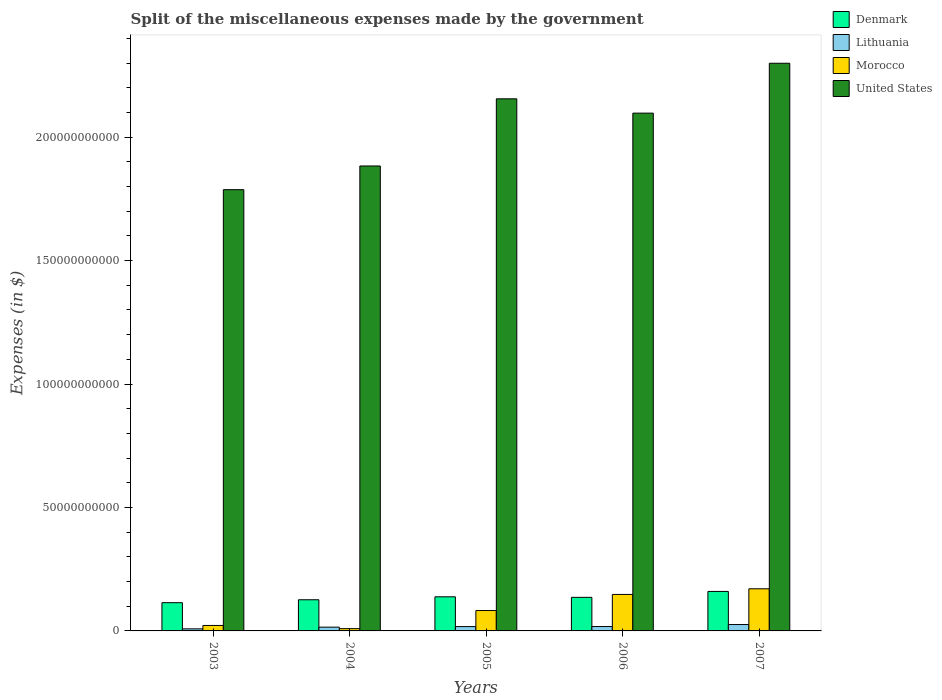How many groups of bars are there?
Your response must be concise. 5. How many bars are there on the 3rd tick from the right?
Offer a very short reply. 4. What is the label of the 3rd group of bars from the left?
Ensure brevity in your answer.  2005. In how many cases, is the number of bars for a given year not equal to the number of legend labels?
Your answer should be very brief. 0. What is the miscellaneous expenses made by the government in Lithuania in 2003?
Your answer should be very brief. 8.38e+08. Across all years, what is the maximum miscellaneous expenses made by the government in Denmark?
Offer a very short reply. 1.60e+1. Across all years, what is the minimum miscellaneous expenses made by the government in Morocco?
Provide a succinct answer. 9.22e+08. What is the total miscellaneous expenses made by the government in Lithuania in the graph?
Your response must be concise. 8.48e+09. What is the difference between the miscellaneous expenses made by the government in Denmark in 2004 and that in 2007?
Give a very brief answer. -3.37e+09. What is the difference between the miscellaneous expenses made by the government in Morocco in 2003 and the miscellaneous expenses made by the government in Lithuania in 2006?
Ensure brevity in your answer.  4.33e+08. What is the average miscellaneous expenses made by the government in United States per year?
Provide a succinct answer. 2.04e+11. In the year 2006, what is the difference between the miscellaneous expenses made by the government in Morocco and miscellaneous expenses made by the government in Denmark?
Provide a short and direct response. 1.18e+09. What is the ratio of the miscellaneous expenses made by the government in Morocco in 2004 to that in 2007?
Keep it short and to the point. 0.05. Is the miscellaneous expenses made by the government in Lithuania in 2003 less than that in 2007?
Keep it short and to the point. Yes. Is the difference between the miscellaneous expenses made by the government in Morocco in 2003 and 2005 greater than the difference between the miscellaneous expenses made by the government in Denmark in 2003 and 2005?
Keep it short and to the point. No. What is the difference between the highest and the second highest miscellaneous expenses made by the government in Denmark?
Provide a succinct answer. 2.17e+09. What is the difference between the highest and the lowest miscellaneous expenses made by the government in Denmark?
Offer a terse response. 4.55e+09. In how many years, is the miscellaneous expenses made by the government in Lithuania greater than the average miscellaneous expenses made by the government in Lithuania taken over all years?
Make the answer very short. 3. Is it the case that in every year, the sum of the miscellaneous expenses made by the government in United States and miscellaneous expenses made by the government in Denmark is greater than the sum of miscellaneous expenses made by the government in Morocco and miscellaneous expenses made by the government in Lithuania?
Your response must be concise. Yes. What does the 4th bar from the right in 2007 represents?
Provide a short and direct response. Denmark. How many bars are there?
Provide a succinct answer. 20. Are all the bars in the graph horizontal?
Your answer should be compact. No. How many years are there in the graph?
Keep it short and to the point. 5. What is the difference between two consecutive major ticks on the Y-axis?
Make the answer very short. 5.00e+1. Are the values on the major ticks of Y-axis written in scientific E-notation?
Keep it short and to the point. No. Does the graph contain any zero values?
Your answer should be compact. No. Where does the legend appear in the graph?
Keep it short and to the point. Top right. How many legend labels are there?
Your answer should be very brief. 4. What is the title of the graph?
Give a very brief answer. Split of the miscellaneous expenses made by the government. What is the label or title of the X-axis?
Offer a very short reply. Years. What is the label or title of the Y-axis?
Make the answer very short. Expenses (in $). What is the Expenses (in $) in Denmark in 2003?
Provide a short and direct response. 1.14e+1. What is the Expenses (in $) of Lithuania in 2003?
Provide a short and direct response. 8.38e+08. What is the Expenses (in $) of Morocco in 2003?
Keep it short and to the point. 2.21e+09. What is the Expenses (in $) in United States in 2003?
Ensure brevity in your answer.  1.79e+11. What is the Expenses (in $) in Denmark in 2004?
Make the answer very short. 1.26e+1. What is the Expenses (in $) of Lithuania in 2004?
Offer a very short reply. 1.53e+09. What is the Expenses (in $) of Morocco in 2004?
Your response must be concise. 9.22e+08. What is the Expenses (in $) of United States in 2004?
Keep it short and to the point. 1.88e+11. What is the Expenses (in $) in Denmark in 2005?
Make the answer very short. 1.38e+1. What is the Expenses (in $) in Lithuania in 2005?
Provide a short and direct response. 1.75e+09. What is the Expenses (in $) of Morocco in 2005?
Provide a succinct answer. 8.26e+09. What is the Expenses (in $) in United States in 2005?
Offer a very short reply. 2.16e+11. What is the Expenses (in $) in Denmark in 2006?
Offer a terse response. 1.36e+1. What is the Expenses (in $) of Lithuania in 2006?
Offer a very short reply. 1.78e+09. What is the Expenses (in $) of Morocco in 2006?
Your answer should be very brief. 1.48e+1. What is the Expenses (in $) of United States in 2006?
Your response must be concise. 2.10e+11. What is the Expenses (in $) in Denmark in 2007?
Your response must be concise. 1.60e+1. What is the Expenses (in $) of Lithuania in 2007?
Provide a short and direct response. 2.58e+09. What is the Expenses (in $) in Morocco in 2007?
Provide a short and direct response. 1.71e+1. What is the Expenses (in $) in United States in 2007?
Offer a very short reply. 2.30e+11. Across all years, what is the maximum Expenses (in $) of Denmark?
Provide a succinct answer. 1.60e+1. Across all years, what is the maximum Expenses (in $) of Lithuania?
Keep it short and to the point. 2.58e+09. Across all years, what is the maximum Expenses (in $) in Morocco?
Your response must be concise. 1.71e+1. Across all years, what is the maximum Expenses (in $) in United States?
Provide a succinct answer. 2.30e+11. Across all years, what is the minimum Expenses (in $) of Denmark?
Provide a succinct answer. 1.14e+1. Across all years, what is the minimum Expenses (in $) of Lithuania?
Ensure brevity in your answer.  8.38e+08. Across all years, what is the minimum Expenses (in $) in Morocco?
Keep it short and to the point. 9.22e+08. Across all years, what is the minimum Expenses (in $) in United States?
Your response must be concise. 1.79e+11. What is the total Expenses (in $) of Denmark in the graph?
Your response must be concise. 6.75e+1. What is the total Expenses (in $) of Lithuania in the graph?
Your answer should be very brief. 8.48e+09. What is the total Expenses (in $) in Morocco in the graph?
Give a very brief answer. 4.32e+1. What is the total Expenses (in $) in United States in the graph?
Your answer should be compact. 1.02e+12. What is the difference between the Expenses (in $) of Denmark in 2003 and that in 2004?
Give a very brief answer. -1.18e+09. What is the difference between the Expenses (in $) in Lithuania in 2003 and that in 2004?
Offer a very short reply. -6.93e+08. What is the difference between the Expenses (in $) in Morocco in 2003 and that in 2004?
Provide a short and direct response. 1.29e+09. What is the difference between the Expenses (in $) of United States in 2003 and that in 2004?
Provide a short and direct response. -9.60e+09. What is the difference between the Expenses (in $) of Denmark in 2003 and that in 2005?
Ensure brevity in your answer.  -2.38e+09. What is the difference between the Expenses (in $) in Lithuania in 2003 and that in 2005?
Your answer should be compact. -9.16e+08. What is the difference between the Expenses (in $) in Morocco in 2003 and that in 2005?
Offer a very short reply. -6.05e+09. What is the difference between the Expenses (in $) in United States in 2003 and that in 2005?
Make the answer very short. -3.68e+1. What is the difference between the Expenses (in $) of Denmark in 2003 and that in 2006?
Offer a very short reply. -2.16e+09. What is the difference between the Expenses (in $) in Lithuania in 2003 and that in 2006?
Provide a succinct answer. -9.38e+08. What is the difference between the Expenses (in $) of Morocco in 2003 and that in 2006?
Your response must be concise. -1.26e+1. What is the difference between the Expenses (in $) in United States in 2003 and that in 2006?
Keep it short and to the point. -3.10e+1. What is the difference between the Expenses (in $) in Denmark in 2003 and that in 2007?
Your response must be concise. -4.55e+09. What is the difference between the Expenses (in $) in Lithuania in 2003 and that in 2007?
Keep it short and to the point. -1.74e+09. What is the difference between the Expenses (in $) of Morocco in 2003 and that in 2007?
Offer a very short reply. -1.49e+1. What is the difference between the Expenses (in $) of United States in 2003 and that in 2007?
Provide a short and direct response. -5.12e+1. What is the difference between the Expenses (in $) in Denmark in 2004 and that in 2005?
Keep it short and to the point. -1.20e+09. What is the difference between the Expenses (in $) in Lithuania in 2004 and that in 2005?
Your response must be concise. -2.23e+08. What is the difference between the Expenses (in $) in Morocco in 2004 and that in 2005?
Your response must be concise. -7.33e+09. What is the difference between the Expenses (in $) of United States in 2004 and that in 2005?
Give a very brief answer. -2.72e+1. What is the difference between the Expenses (in $) in Denmark in 2004 and that in 2006?
Ensure brevity in your answer.  -9.76e+08. What is the difference between the Expenses (in $) in Lithuania in 2004 and that in 2006?
Provide a short and direct response. -2.45e+08. What is the difference between the Expenses (in $) of Morocco in 2004 and that in 2006?
Give a very brief answer. -1.38e+1. What is the difference between the Expenses (in $) in United States in 2004 and that in 2006?
Offer a very short reply. -2.14e+1. What is the difference between the Expenses (in $) in Denmark in 2004 and that in 2007?
Your answer should be compact. -3.37e+09. What is the difference between the Expenses (in $) in Lithuania in 2004 and that in 2007?
Ensure brevity in your answer.  -1.05e+09. What is the difference between the Expenses (in $) of Morocco in 2004 and that in 2007?
Ensure brevity in your answer.  -1.61e+1. What is the difference between the Expenses (in $) of United States in 2004 and that in 2007?
Your response must be concise. -4.16e+1. What is the difference between the Expenses (in $) of Denmark in 2005 and that in 2006?
Ensure brevity in your answer.  2.23e+08. What is the difference between the Expenses (in $) of Lithuania in 2005 and that in 2006?
Keep it short and to the point. -2.16e+07. What is the difference between the Expenses (in $) of Morocco in 2005 and that in 2006?
Your response must be concise. -6.52e+09. What is the difference between the Expenses (in $) of United States in 2005 and that in 2006?
Ensure brevity in your answer.  5.80e+09. What is the difference between the Expenses (in $) of Denmark in 2005 and that in 2007?
Offer a terse response. -2.17e+09. What is the difference between the Expenses (in $) in Lithuania in 2005 and that in 2007?
Provide a short and direct response. -8.28e+08. What is the difference between the Expenses (in $) in Morocco in 2005 and that in 2007?
Provide a short and direct response. -8.81e+09. What is the difference between the Expenses (in $) in United States in 2005 and that in 2007?
Your response must be concise. -1.44e+1. What is the difference between the Expenses (in $) of Denmark in 2006 and that in 2007?
Your answer should be very brief. -2.40e+09. What is the difference between the Expenses (in $) in Lithuania in 2006 and that in 2007?
Keep it short and to the point. -8.07e+08. What is the difference between the Expenses (in $) of Morocco in 2006 and that in 2007?
Make the answer very short. -2.29e+09. What is the difference between the Expenses (in $) in United States in 2006 and that in 2007?
Provide a succinct answer. -2.02e+1. What is the difference between the Expenses (in $) in Denmark in 2003 and the Expenses (in $) in Lithuania in 2004?
Offer a terse response. 9.91e+09. What is the difference between the Expenses (in $) in Denmark in 2003 and the Expenses (in $) in Morocco in 2004?
Give a very brief answer. 1.05e+1. What is the difference between the Expenses (in $) of Denmark in 2003 and the Expenses (in $) of United States in 2004?
Provide a short and direct response. -1.77e+11. What is the difference between the Expenses (in $) in Lithuania in 2003 and the Expenses (in $) in Morocco in 2004?
Provide a succinct answer. -8.35e+07. What is the difference between the Expenses (in $) in Lithuania in 2003 and the Expenses (in $) in United States in 2004?
Provide a short and direct response. -1.87e+11. What is the difference between the Expenses (in $) in Morocco in 2003 and the Expenses (in $) in United States in 2004?
Your answer should be very brief. -1.86e+11. What is the difference between the Expenses (in $) in Denmark in 2003 and the Expenses (in $) in Lithuania in 2005?
Offer a terse response. 9.68e+09. What is the difference between the Expenses (in $) of Denmark in 2003 and the Expenses (in $) of Morocco in 2005?
Your answer should be very brief. 3.18e+09. What is the difference between the Expenses (in $) of Denmark in 2003 and the Expenses (in $) of United States in 2005?
Your response must be concise. -2.04e+11. What is the difference between the Expenses (in $) in Lithuania in 2003 and the Expenses (in $) in Morocco in 2005?
Keep it short and to the point. -7.42e+09. What is the difference between the Expenses (in $) in Lithuania in 2003 and the Expenses (in $) in United States in 2005?
Ensure brevity in your answer.  -2.15e+11. What is the difference between the Expenses (in $) of Morocco in 2003 and the Expenses (in $) of United States in 2005?
Ensure brevity in your answer.  -2.13e+11. What is the difference between the Expenses (in $) of Denmark in 2003 and the Expenses (in $) of Lithuania in 2006?
Give a very brief answer. 9.66e+09. What is the difference between the Expenses (in $) of Denmark in 2003 and the Expenses (in $) of Morocco in 2006?
Keep it short and to the point. -3.33e+09. What is the difference between the Expenses (in $) in Denmark in 2003 and the Expenses (in $) in United States in 2006?
Provide a succinct answer. -1.98e+11. What is the difference between the Expenses (in $) in Lithuania in 2003 and the Expenses (in $) in Morocco in 2006?
Make the answer very short. -1.39e+1. What is the difference between the Expenses (in $) in Lithuania in 2003 and the Expenses (in $) in United States in 2006?
Your answer should be compact. -2.09e+11. What is the difference between the Expenses (in $) in Morocco in 2003 and the Expenses (in $) in United States in 2006?
Offer a very short reply. -2.07e+11. What is the difference between the Expenses (in $) in Denmark in 2003 and the Expenses (in $) in Lithuania in 2007?
Your answer should be very brief. 8.86e+09. What is the difference between the Expenses (in $) of Denmark in 2003 and the Expenses (in $) of Morocco in 2007?
Offer a very short reply. -5.63e+09. What is the difference between the Expenses (in $) in Denmark in 2003 and the Expenses (in $) in United States in 2007?
Your answer should be compact. -2.18e+11. What is the difference between the Expenses (in $) of Lithuania in 2003 and the Expenses (in $) of Morocco in 2007?
Your response must be concise. -1.62e+1. What is the difference between the Expenses (in $) in Lithuania in 2003 and the Expenses (in $) in United States in 2007?
Your response must be concise. -2.29e+11. What is the difference between the Expenses (in $) in Morocco in 2003 and the Expenses (in $) in United States in 2007?
Give a very brief answer. -2.28e+11. What is the difference between the Expenses (in $) in Denmark in 2004 and the Expenses (in $) in Lithuania in 2005?
Offer a terse response. 1.09e+1. What is the difference between the Expenses (in $) of Denmark in 2004 and the Expenses (in $) of Morocco in 2005?
Give a very brief answer. 4.36e+09. What is the difference between the Expenses (in $) of Denmark in 2004 and the Expenses (in $) of United States in 2005?
Your response must be concise. -2.03e+11. What is the difference between the Expenses (in $) of Lithuania in 2004 and the Expenses (in $) of Morocco in 2005?
Provide a short and direct response. -6.72e+09. What is the difference between the Expenses (in $) in Lithuania in 2004 and the Expenses (in $) in United States in 2005?
Provide a succinct answer. -2.14e+11. What is the difference between the Expenses (in $) in Morocco in 2004 and the Expenses (in $) in United States in 2005?
Provide a succinct answer. -2.15e+11. What is the difference between the Expenses (in $) in Denmark in 2004 and the Expenses (in $) in Lithuania in 2006?
Provide a short and direct response. 1.08e+1. What is the difference between the Expenses (in $) in Denmark in 2004 and the Expenses (in $) in Morocco in 2006?
Make the answer very short. -2.15e+09. What is the difference between the Expenses (in $) of Denmark in 2004 and the Expenses (in $) of United States in 2006?
Your response must be concise. -1.97e+11. What is the difference between the Expenses (in $) of Lithuania in 2004 and the Expenses (in $) of Morocco in 2006?
Your answer should be compact. -1.32e+1. What is the difference between the Expenses (in $) of Lithuania in 2004 and the Expenses (in $) of United States in 2006?
Your answer should be compact. -2.08e+11. What is the difference between the Expenses (in $) of Morocco in 2004 and the Expenses (in $) of United States in 2006?
Provide a succinct answer. -2.09e+11. What is the difference between the Expenses (in $) in Denmark in 2004 and the Expenses (in $) in Lithuania in 2007?
Your answer should be compact. 1.00e+1. What is the difference between the Expenses (in $) in Denmark in 2004 and the Expenses (in $) in Morocco in 2007?
Your answer should be compact. -4.44e+09. What is the difference between the Expenses (in $) in Denmark in 2004 and the Expenses (in $) in United States in 2007?
Your answer should be compact. -2.17e+11. What is the difference between the Expenses (in $) in Lithuania in 2004 and the Expenses (in $) in Morocco in 2007?
Your answer should be very brief. -1.55e+1. What is the difference between the Expenses (in $) in Lithuania in 2004 and the Expenses (in $) in United States in 2007?
Provide a succinct answer. -2.28e+11. What is the difference between the Expenses (in $) of Morocco in 2004 and the Expenses (in $) of United States in 2007?
Your answer should be very brief. -2.29e+11. What is the difference between the Expenses (in $) of Denmark in 2005 and the Expenses (in $) of Lithuania in 2006?
Ensure brevity in your answer.  1.20e+1. What is the difference between the Expenses (in $) in Denmark in 2005 and the Expenses (in $) in Morocco in 2006?
Provide a short and direct response. -9.52e+08. What is the difference between the Expenses (in $) in Denmark in 2005 and the Expenses (in $) in United States in 2006?
Ensure brevity in your answer.  -1.96e+11. What is the difference between the Expenses (in $) in Lithuania in 2005 and the Expenses (in $) in Morocco in 2006?
Provide a short and direct response. -1.30e+1. What is the difference between the Expenses (in $) in Lithuania in 2005 and the Expenses (in $) in United States in 2006?
Your answer should be very brief. -2.08e+11. What is the difference between the Expenses (in $) of Morocco in 2005 and the Expenses (in $) of United States in 2006?
Your answer should be very brief. -2.01e+11. What is the difference between the Expenses (in $) in Denmark in 2005 and the Expenses (in $) in Lithuania in 2007?
Provide a succinct answer. 1.12e+1. What is the difference between the Expenses (in $) in Denmark in 2005 and the Expenses (in $) in Morocco in 2007?
Your response must be concise. -3.25e+09. What is the difference between the Expenses (in $) in Denmark in 2005 and the Expenses (in $) in United States in 2007?
Your answer should be compact. -2.16e+11. What is the difference between the Expenses (in $) of Lithuania in 2005 and the Expenses (in $) of Morocco in 2007?
Give a very brief answer. -1.53e+1. What is the difference between the Expenses (in $) in Lithuania in 2005 and the Expenses (in $) in United States in 2007?
Provide a short and direct response. -2.28e+11. What is the difference between the Expenses (in $) of Morocco in 2005 and the Expenses (in $) of United States in 2007?
Keep it short and to the point. -2.22e+11. What is the difference between the Expenses (in $) of Denmark in 2006 and the Expenses (in $) of Lithuania in 2007?
Give a very brief answer. 1.10e+1. What is the difference between the Expenses (in $) in Denmark in 2006 and the Expenses (in $) in Morocco in 2007?
Make the answer very short. -3.47e+09. What is the difference between the Expenses (in $) of Denmark in 2006 and the Expenses (in $) of United States in 2007?
Offer a terse response. -2.16e+11. What is the difference between the Expenses (in $) of Lithuania in 2006 and the Expenses (in $) of Morocco in 2007?
Offer a terse response. -1.53e+1. What is the difference between the Expenses (in $) in Lithuania in 2006 and the Expenses (in $) in United States in 2007?
Your answer should be compact. -2.28e+11. What is the difference between the Expenses (in $) of Morocco in 2006 and the Expenses (in $) of United States in 2007?
Offer a very short reply. -2.15e+11. What is the average Expenses (in $) of Denmark per year?
Your response must be concise. 1.35e+1. What is the average Expenses (in $) of Lithuania per year?
Offer a terse response. 1.70e+09. What is the average Expenses (in $) in Morocco per year?
Your answer should be very brief. 8.64e+09. What is the average Expenses (in $) in United States per year?
Provide a succinct answer. 2.04e+11. In the year 2003, what is the difference between the Expenses (in $) in Denmark and Expenses (in $) in Lithuania?
Provide a short and direct response. 1.06e+1. In the year 2003, what is the difference between the Expenses (in $) of Denmark and Expenses (in $) of Morocco?
Your answer should be very brief. 9.23e+09. In the year 2003, what is the difference between the Expenses (in $) in Denmark and Expenses (in $) in United States?
Keep it short and to the point. -1.67e+11. In the year 2003, what is the difference between the Expenses (in $) of Lithuania and Expenses (in $) of Morocco?
Your answer should be very brief. -1.37e+09. In the year 2003, what is the difference between the Expenses (in $) in Lithuania and Expenses (in $) in United States?
Give a very brief answer. -1.78e+11. In the year 2003, what is the difference between the Expenses (in $) in Morocco and Expenses (in $) in United States?
Your answer should be very brief. -1.76e+11. In the year 2004, what is the difference between the Expenses (in $) of Denmark and Expenses (in $) of Lithuania?
Make the answer very short. 1.11e+1. In the year 2004, what is the difference between the Expenses (in $) in Denmark and Expenses (in $) in Morocco?
Ensure brevity in your answer.  1.17e+1. In the year 2004, what is the difference between the Expenses (in $) of Denmark and Expenses (in $) of United States?
Offer a terse response. -1.76e+11. In the year 2004, what is the difference between the Expenses (in $) of Lithuania and Expenses (in $) of Morocco?
Make the answer very short. 6.09e+08. In the year 2004, what is the difference between the Expenses (in $) of Lithuania and Expenses (in $) of United States?
Your answer should be compact. -1.87e+11. In the year 2004, what is the difference between the Expenses (in $) in Morocco and Expenses (in $) in United States?
Provide a short and direct response. -1.87e+11. In the year 2005, what is the difference between the Expenses (in $) in Denmark and Expenses (in $) in Lithuania?
Offer a terse response. 1.21e+1. In the year 2005, what is the difference between the Expenses (in $) of Denmark and Expenses (in $) of Morocco?
Keep it short and to the point. 5.56e+09. In the year 2005, what is the difference between the Expenses (in $) of Denmark and Expenses (in $) of United States?
Offer a terse response. -2.02e+11. In the year 2005, what is the difference between the Expenses (in $) in Lithuania and Expenses (in $) in Morocco?
Keep it short and to the point. -6.50e+09. In the year 2005, what is the difference between the Expenses (in $) in Lithuania and Expenses (in $) in United States?
Make the answer very short. -2.14e+11. In the year 2005, what is the difference between the Expenses (in $) of Morocco and Expenses (in $) of United States?
Offer a very short reply. -2.07e+11. In the year 2006, what is the difference between the Expenses (in $) in Denmark and Expenses (in $) in Lithuania?
Offer a very short reply. 1.18e+1. In the year 2006, what is the difference between the Expenses (in $) in Denmark and Expenses (in $) in Morocco?
Your answer should be compact. -1.18e+09. In the year 2006, what is the difference between the Expenses (in $) in Denmark and Expenses (in $) in United States?
Your response must be concise. -1.96e+11. In the year 2006, what is the difference between the Expenses (in $) in Lithuania and Expenses (in $) in Morocco?
Make the answer very short. -1.30e+1. In the year 2006, what is the difference between the Expenses (in $) in Lithuania and Expenses (in $) in United States?
Offer a terse response. -2.08e+11. In the year 2006, what is the difference between the Expenses (in $) in Morocco and Expenses (in $) in United States?
Make the answer very short. -1.95e+11. In the year 2007, what is the difference between the Expenses (in $) of Denmark and Expenses (in $) of Lithuania?
Your response must be concise. 1.34e+1. In the year 2007, what is the difference between the Expenses (in $) of Denmark and Expenses (in $) of Morocco?
Ensure brevity in your answer.  -1.07e+09. In the year 2007, what is the difference between the Expenses (in $) of Denmark and Expenses (in $) of United States?
Your answer should be compact. -2.14e+11. In the year 2007, what is the difference between the Expenses (in $) of Lithuania and Expenses (in $) of Morocco?
Ensure brevity in your answer.  -1.45e+1. In the year 2007, what is the difference between the Expenses (in $) in Lithuania and Expenses (in $) in United States?
Give a very brief answer. -2.27e+11. In the year 2007, what is the difference between the Expenses (in $) of Morocco and Expenses (in $) of United States?
Give a very brief answer. -2.13e+11. What is the ratio of the Expenses (in $) in Denmark in 2003 to that in 2004?
Give a very brief answer. 0.91. What is the ratio of the Expenses (in $) of Lithuania in 2003 to that in 2004?
Your response must be concise. 0.55. What is the ratio of the Expenses (in $) of Morocco in 2003 to that in 2004?
Your answer should be compact. 2.4. What is the ratio of the Expenses (in $) in United States in 2003 to that in 2004?
Your answer should be compact. 0.95. What is the ratio of the Expenses (in $) of Denmark in 2003 to that in 2005?
Give a very brief answer. 0.83. What is the ratio of the Expenses (in $) in Lithuania in 2003 to that in 2005?
Make the answer very short. 0.48. What is the ratio of the Expenses (in $) in Morocco in 2003 to that in 2005?
Offer a terse response. 0.27. What is the ratio of the Expenses (in $) in United States in 2003 to that in 2005?
Offer a very short reply. 0.83. What is the ratio of the Expenses (in $) in Denmark in 2003 to that in 2006?
Your response must be concise. 0.84. What is the ratio of the Expenses (in $) in Lithuania in 2003 to that in 2006?
Give a very brief answer. 0.47. What is the ratio of the Expenses (in $) of Morocco in 2003 to that in 2006?
Ensure brevity in your answer.  0.15. What is the ratio of the Expenses (in $) in United States in 2003 to that in 2006?
Ensure brevity in your answer.  0.85. What is the ratio of the Expenses (in $) in Denmark in 2003 to that in 2007?
Your answer should be very brief. 0.72. What is the ratio of the Expenses (in $) of Lithuania in 2003 to that in 2007?
Make the answer very short. 0.32. What is the ratio of the Expenses (in $) of Morocco in 2003 to that in 2007?
Provide a succinct answer. 0.13. What is the ratio of the Expenses (in $) of United States in 2003 to that in 2007?
Offer a terse response. 0.78. What is the ratio of the Expenses (in $) in Denmark in 2004 to that in 2005?
Provide a short and direct response. 0.91. What is the ratio of the Expenses (in $) in Lithuania in 2004 to that in 2005?
Your answer should be very brief. 0.87. What is the ratio of the Expenses (in $) in Morocco in 2004 to that in 2005?
Offer a terse response. 0.11. What is the ratio of the Expenses (in $) in United States in 2004 to that in 2005?
Give a very brief answer. 0.87. What is the ratio of the Expenses (in $) in Denmark in 2004 to that in 2006?
Make the answer very short. 0.93. What is the ratio of the Expenses (in $) of Lithuania in 2004 to that in 2006?
Ensure brevity in your answer.  0.86. What is the ratio of the Expenses (in $) in Morocco in 2004 to that in 2006?
Ensure brevity in your answer.  0.06. What is the ratio of the Expenses (in $) in United States in 2004 to that in 2006?
Keep it short and to the point. 0.9. What is the ratio of the Expenses (in $) of Denmark in 2004 to that in 2007?
Provide a short and direct response. 0.79. What is the ratio of the Expenses (in $) of Lithuania in 2004 to that in 2007?
Offer a terse response. 0.59. What is the ratio of the Expenses (in $) of Morocco in 2004 to that in 2007?
Your response must be concise. 0.05. What is the ratio of the Expenses (in $) in United States in 2004 to that in 2007?
Give a very brief answer. 0.82. What is the ratio of the Expenses (in $) in Denmark in 2005 to that in 2006?
Ensure brevity in your answer.  1.02. What is the ratio of the Expenses (in $) of Lithuania in 2005 to that in 2006?
Give a very brief answer. 0.99. What is the ratio of the Expenses (in $) of Morocco in 2005 to that in 2006?
Your answer should be very brief. 0.56. What is the ratio of the Expenses (in $) in United States in 2005 to that in 2006?
Keep it short and to the point. 1.03. What is the ratio of the Expenses (in $) of Denmark in 2005 to that in 2007?
Offer a very short reply. 0.86. What is the ratio of the Expenses (in $) of Lithuania in 2005 to that in 2007?
Provide a short and direct response. 0.68. What is the ratio of the Expenses (in $) in Morocco in 2005 to that in 2007?
Your answer should be very brief. 0.48. What is the ratio of the Expenses (in $) in United States in 2005 to that in 2007?
Provide a short and direct response. 0.94. What is the ratio of the Expenses (in $) of Denmark in 2006 to that in 2007?
Offer a terse response. 0.85. What is the ratio of the Expenses (in $) of Lithuania in 2006 to that in 2007?
Keep it short and to the point. 0.69. What is the ratio of the Expenses (in $) in Morocco in 2006 to that in 2007?
Offer a very short reply. 0.87. What is the ratio of the Expenses (in $) of United States in 2006 to that in 2007?
Provide a succinct answer. 0.91. What is the difference between the highest and the second highest Expenses (in $) in Denmark?
Keep it short and to the point. 2.17e+09. What is the difference between the highest and the second highest Expenses (in $) of Lithuania?
Make the answer very short. 8.07e+08. What is the difference between the highest and the second highest Expenses (in $) in Morocco?
Provide a succinct answer. 2.29e+09. What is the difference between the highest and the second highest Expenses (in $) of United States?
Your answer should be compact. 1.44e+1. What is the difference between the highest and the lowest Expenses (in $) of Denmark?
Keep it short and to the point. 4.55e+09. What is the difference between the highest and the lowest Expenses (in $) of Lithuania?
Make the answer very short. 1.74e+09. What is the difference between the highest and the lowest Expenses (in $) in Morocco?
Keep it short and to the point. 1.61e+1. What is the difference between the highest and the lowest Expenses (in $) of United States?
Make the answer very short. 5.12e+1. 